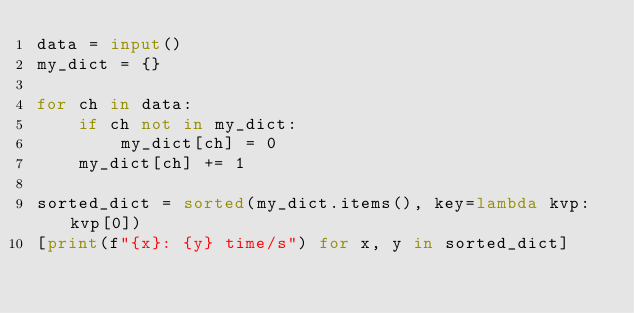Convert code to text. <code><loc_0><loc_0><loc_500><loc_500><_Python_>data = input()
my_dict = {}

for ch in data:
    if ch not in my_dict:
        my_dict[ch] = 0
    my_dict[ch] += 1

sorted_dict = sorted(my_dict.items(), key=lambda kvp: kvp[0])
[print(f"{x}: {y} time/s") for x, y in sorted_dict]
</code> 